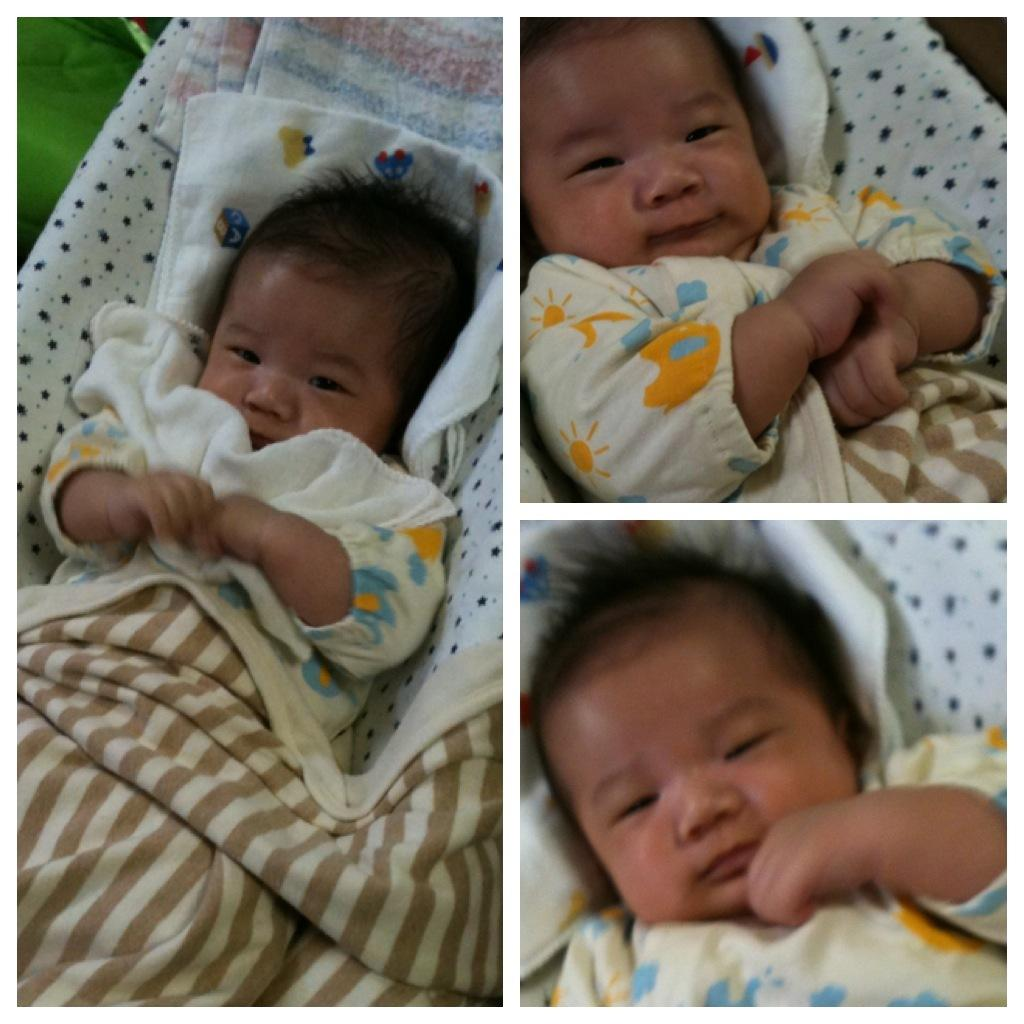What is the main subject of the image? The main subject of the image is a baby. How many instances of the baby are present in the image? The image is a collage of the same baby. What is the baby laying on in the image? The baby is laying on a cloth surface. What is covering the baby in the image? There is a baby blanket above the baby. Can you hear the baby singing a song in the image? There is no sound in the image, so it is not possible to hear the baby singing a song. 